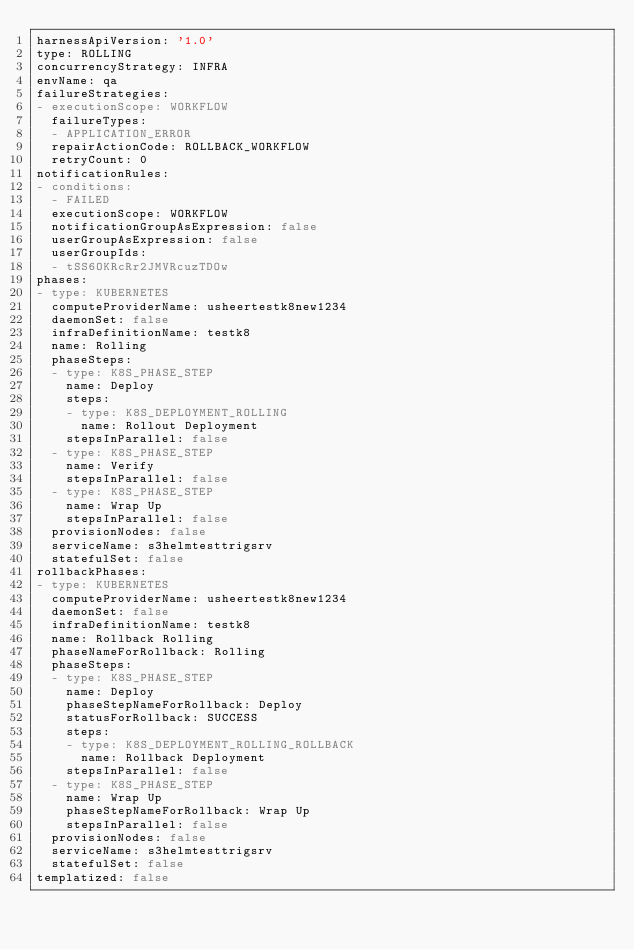<code> <loc_0><loc_0><loc_500><loc_500><_YAML_>harnessApiVersion: '1.0'
type: ROLLING
concurrencyStrategy: INFRA
envName: qa
failureStrategies:
- executionScope: WORKFLOW
  failureTypes:
  - APPLICATION_ERROR
  repairActionCode: ROLLBACK_WORKFLOW
  retryCount: 0
notificationRules:
- conditions:
  - FAILED
  executionScope: WORKFLOW
  notificationGroupAsExpression: false
  userGroupAsExpression: false
  userGroupIds:
  - tSS6OKRcRr2JMVRcuzTDOw
phases:
- type: KUBERNETES
  computeProviderName: usheertestk8new1234
  daemonSet: false
  infraDefinitionName: testk8
  name: Rolling
  phaseSteps:
  - type: K8S_PHASE_STEP
    name: Deploy
    steps:
    - type: K8S_DEPLOYMENT_ROLLING
      name: Rollout Deployment
    stepsInParallel: false
  - type: K8S_PHASE_STEP
    name: Verify
    stepsInParallel: false
  - type: K8S_PHASE_STEP
    name: Wrap Up
    stepsInParallel: false
  provisionNodes: false
  serviceName: s3helmtesttrigsrv
  statefulSet: false
rollbackPhases:
- type: KUBERNETES
  computeProviderName: usheertestk8new1234
  daemonSet: false
  infraDefinitionName: testk8
  name: Rollback Rolling
  phaseNameForRollback: Rolling
  phaseSteps:
  - type: K8S_PHASE_STEP
    name: Deploy
    phaseStepNameForRollback: Deploy
    statusForRollback: SUCCESS
    steps:
    - type: K8S_DEPLOYMENT_ROLLING_ROLLBACK
      name: Rollback Deployment
    stepsInParallel: false
  - type: K8S_PHASE_STEP
    name: Wrap Up
    phaseStepNameForRollback: Wrap Up
    stepsInParallel: false
  provisionNodes: false
  serviceName: s3helmtesttrigsrv
  statefulSet: false
templatized: false
</code> 